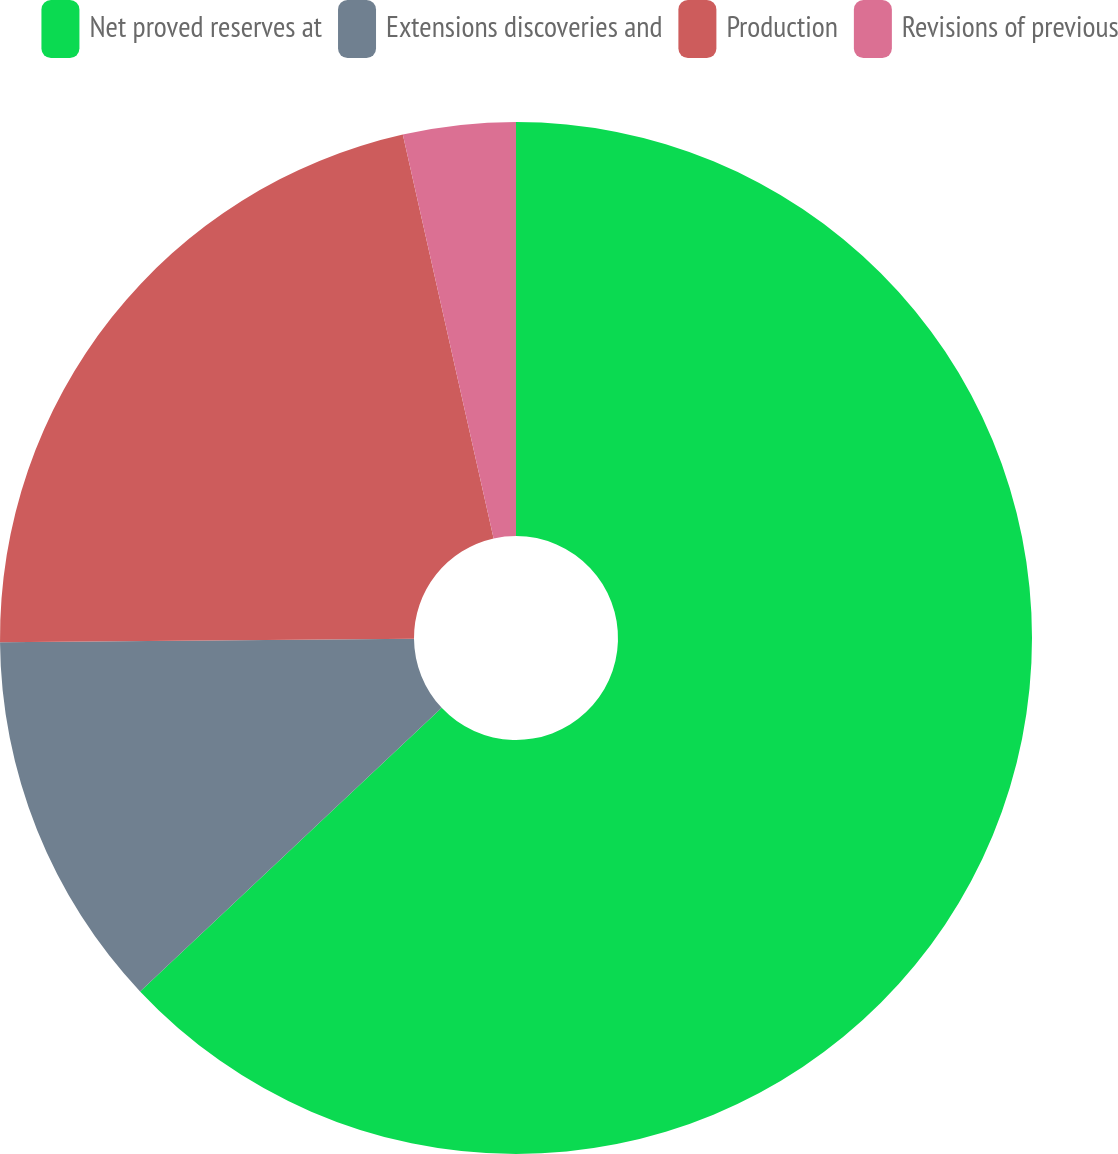Convert chart to OTSL. <chart><loc_0><loc_0><loc_500><loc_500><pie_chart><fcel>Net proved reserves at<fcel>Extensions discoveries and<fcel>Production<fcel>Revisions of previous<nl><fcel>62.99%<fcel>11.88%<fcel>21.61%<fcel>3.52%<nl></chart> 